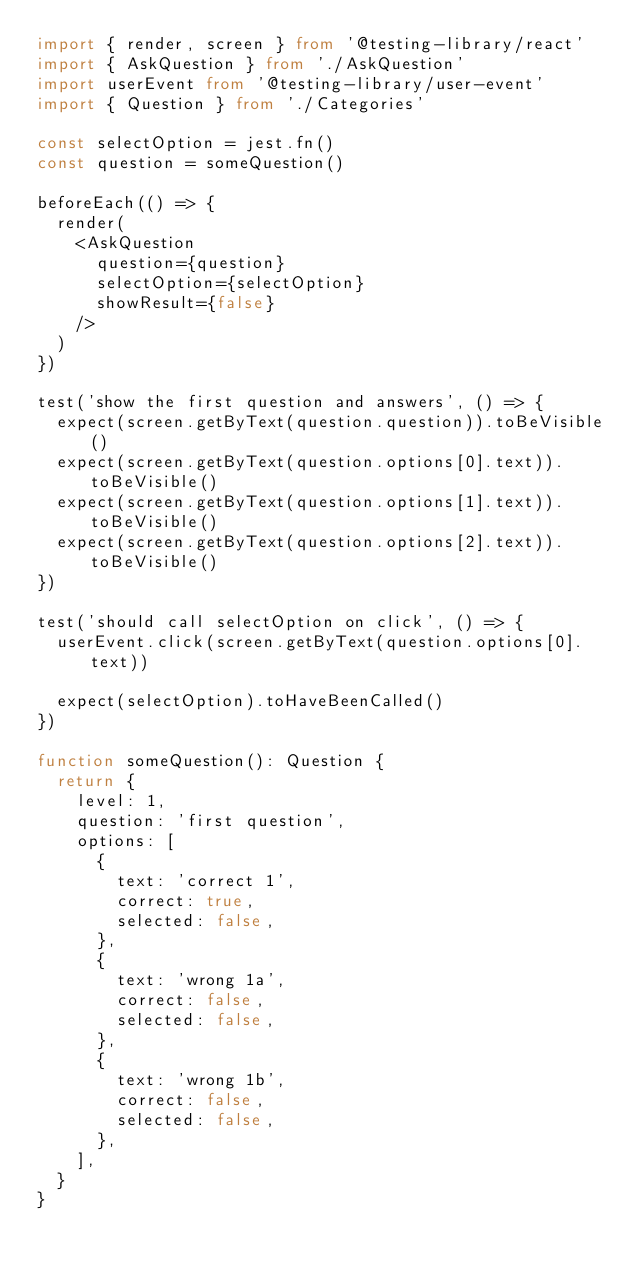<code> <loc_0><loc_0><loc_500><loc_500><_TypeScript_>import { render, screen } from '@testing-library/react'
import { AskQuestion } from './AskQuestion'
import userEvent from '@testing-library/user-event'
import { Question } from './Categories'

const selectOption = jest.fn()
const question = someQuestion()

beforeEach(() => {
  render(
    <AskQuestion
      question={question}
      selectOption={selectOption}
      showResult={false}
    />
  )
})

test('show the first question and answers', () => {
  expect(screen.getByText(question.question)).toBeVisible()
  expect(screen.getByText(question.options[0].text)).toBeVisible()
  expect(screen.getByText(question.options[1].text)).toBeVisible()
  expect(screen.getByText(question.options[2].text)).toBeVisible()
})

test('should call selectOption on click', () => {
  userEvent.click(screen.getByText(question.options[0].text))

  expect(selectOption).toHaveBeenCalled()
})

function someQuestion(): Question {
  return {
    level: 1,
    question: 'first question',
    options: [
      {
        text: 'correct 1',
        correct: true,
        selected: false,
      },
      {
        text: 'wrong 1a',
        correct: false,
        selected: false,
      },
      {
        text: 'wrong 1b',
        correct: false,
        selected: false,
      },
    ],
  }
}
</code> 